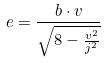<formula> <loc_0><loc_0><loc_500><loc_500>e = \frac { b \cdot v } { \sqrt { 8 - \frac { v ^ { 2 } } { j ^ { 2 } } } }</formula> 